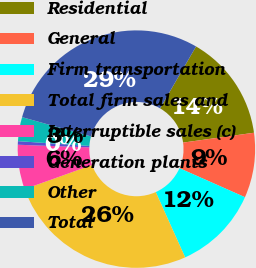Convert chart to OTSL. <chart><loc_0><loc_0><loc_500><loc_500><pie_chart><fcel>Residential<fcel>General<fcel>Firm transportation<fcel>Total firm sales and<fcel>Interruptible sales (c)<fcel>Generation plants<fcel>Other<fcel>Total<nl><fcel>14.42%<fcel>8.84%<fcel>11.63%<fcel>26.26%<fcel>6.06%<fcel>0.48%<fcel>3.27%<fcel>29.04%<nl></chart> 